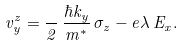<formula> <loc_0><loc_0><loc_500><loc_500>v ^ { z } _ { y } = \frac { } { 2 } \, \frac { \hbar { k } _ { y } } { m ^ { \ast } } \, \sigma _ { z } - e \lambda \, E _ { x } .</formula> 